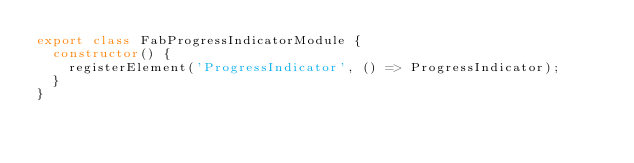<code> <loc_0><loc_0><loc_500><loc_500><_TypeScript_>export class FabProgressIndicatorModule {
  constructor() {
    registerElement('ProgressIndicator', () => ProgressIndicator);
  }
}
</code> 